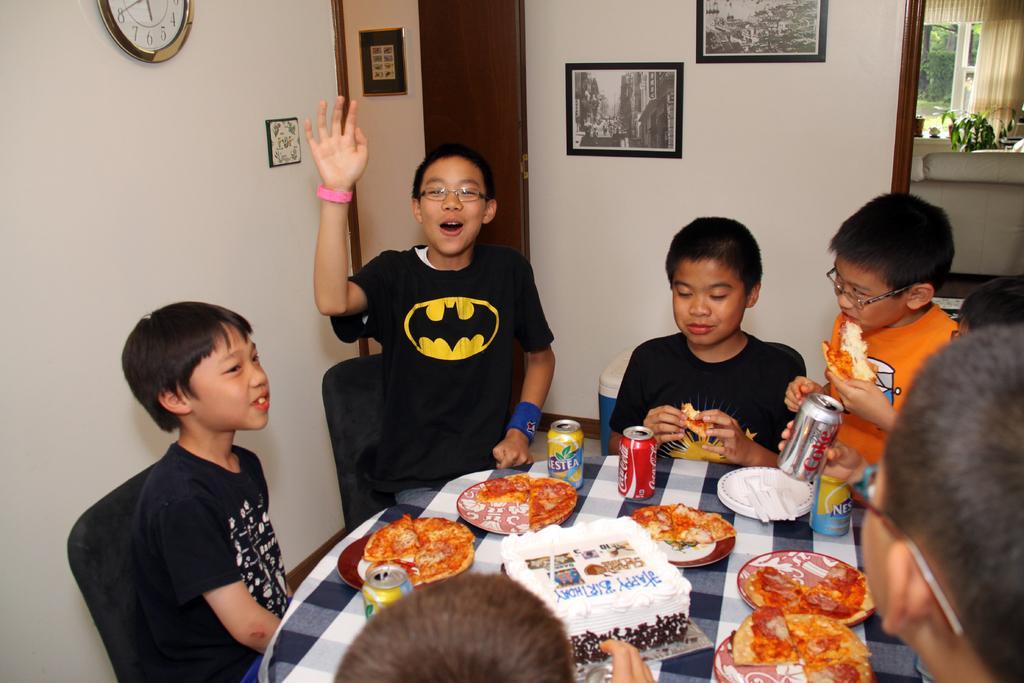Can you describe this image briefly? There are five kids. between them there is a table. On the table there are plates, forks, coke tins, pizza, Birthday cake. And to the left side wall there is a clock. And in the middle wall there are two frames. In the right side top corner there is a sofa, curtain and window. And there is a door. 